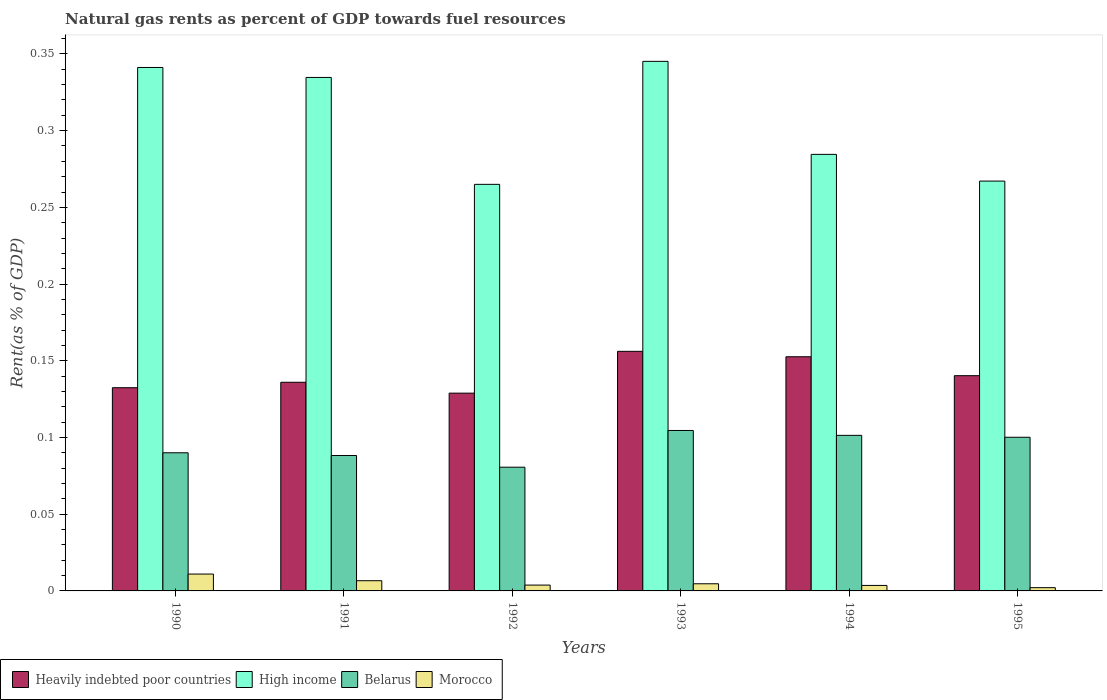Are the number of bars per tick equal to the number of legend labels?
Provide a short and direct response. Yes. How many bars are there on the 5th tick from the left?
Your answer should be very brief. 4. What is the label of the 2nd group of bars from the left?
Provide a short and direct response. 1991. In how many cases, is the number of bars for a given year not equal to the number of legend labels?
Make the answer very short. 0. What is the matural gas rent in Heavily indebted poor countries in 1995?
Provide a succinct answer. 0.14. Across all years, what is the maximum matural gas rent in Morocco?
Ensure brevity in your answer.  0.01. Across all years, what is the minimum matural gas rent in Belarus?
Make the answer very short. 0.08. In which year was the matural gas rent in Belarus maximum?
Your response must be concise. 1993. What is the total matural gas rent in High income in the graph?
Offer a very short reply. 1.84. What is the difference between the matural gas rent in Belarus in 1992 and that in 1995?
Give a very brief answer. -0.02. What is the difference between the matural gas rent in Heavily indebted poor countries in 1994 and the matural gas rent in High income in 1990?
Provide a short and direct response. -0.19. What is the average matural gas rent in Morocco per year?
Your response must be concise. 0.01. In the year 1990, what is the difference between the matural gas rent in Belarus and matural gas rent in Morocco?
Keep it short and to the point. 0.08. In how many years, is the matural gas rent in High income greater than 0.17 %?
Make the answer very short. 6. What is the ratio of the matural gas rent in Morocco in 1992 to that in 1995?
Provide a succinct answer. 1.79. Is the difference between the matural gas rent in Belarus in 1991 and 1992 greater than the difference between the matural gas rent in Morocco in 1991 and 1992?
Your response must be concise. Yes. What is the difference between the highest and the second highest matural gas rent in Heavily indebted poor countries?
Your answer should be compact. 0. What is the difference between the highest and the lowest matural gas rent in Heavily indebted poor countries?
Your response must be concise. 0.03. In how many years, is the matural gas rent in Heavily indebted poor countries greater than the average matural gas rent in Heavily indebted poor countries taken over all years?
Offer a terse response. 2. Is the sum of the matural gas rent in Morocco in 1993 and 1995 greater than the maximum matural gas rent in Heavily indebted poor countries across all years?
Your answer should be compact. No. What does the 2nd bar from the right in 1993 represents?
Make the answer very short. Belarus. How many bars are there?
Offer a very short reply. 24. Are all the bars in the graph horizontal?
Give a very brief answer. No. Are the values on the major ticks of Y-axis written in scientific E-notation?
Keep it short and to the point. No. Does the graph contain grids?
Provide a succinct answer. No. Where does the legend appear in the graph?
Make the answer very short. Bottom left. How many legend labels are there?
Give a very brief answer. 4. What is the title of the graph?
Make the answer very short. Natural gas rents as percent of GDP towards fuel resources. What is the label or title of the Y-axis?
Your answer should be compact. Rent(as % of GDP). What is the Rent(as % of GDP) of Heavily indebted poor countries in 1990?
Ensure brevity in your answer.  0.13. What is the Rent(as % of GDP) in High income in 1990?
Your answer should be compact. 0.34. What is the Rent(as % of GDP) in Belarus in 1990?
Ensure brevity in your answer.  0.09. What is the Rent(as % of GDP) in Morocco in 1990?
Provide a succinct answer. 0.01. What is the Rent(as % of GDP) in Heavily indebted poor countries in 1991?
Offer a terse response. 0.14. What is the Rent(as % of GDP) of High income in 1991?
Make the answer very short. 0.33. What is the Rent(as % of GDP) of Belarus in 1991?
Make the answer very short. 0.09. What is the Rent(as % of GDP) in Morocco in 1991?
Provide a short and direct response. 0.01. What is the Rent(as % of GDP) in Heavily indebted poor countries in 1992?
Provide a succinct answer. 0.13. What is the Rent(as % of GDP) of High income in 1992?
Your answer should be very brief. 0.26. What is the Rent(as % of GDP) of Belarus in 1992?
Offer a very short reply. 0.08. What is the Rent(as % of GDP) in Morocco in 1992?
Keep it short and to the point. 0. What is the Rent(as % of GDP) of Heavily indebted poor countries in 1993?
Your answer should be compact. 0.16. What is the Rent(as % of GDP) in High income in 1993?
Provide a succinct answer. 0.35. What is the Rent(as % of GDP) of Belarus in 1993?
Offer a terse response. 0.1. What is the Rent(as % of GDP) of Morocco in 1993?
Keep it short and to the point. 0. What is the Rent(as % of GDP) of Heavily indebted poor countries in 1994?
Provide a succinct answer. 0.15. What is the Rent(as % of GDP) in High income in 1994?
Provide a succinct answer. 0.28. What is the Rent(as % of GDP) of Belarus in 1994?
Your answer should be compact. 0.1. What is the Rent(as % of GDP) in Morocco in 1994?
Give a very brief answer. 0. What is the Rent(as % of GDP) of Heavily indebted poor countries in 1995?
Offer a terse response. 0.14. What is the Rent(as % of GDP) in High income in 1995?
Provide a succinct answer. 0.27. What is the Rent(as % of GDP) in Belarus in 1995?
Ensure brevity in your answer.  0.1. What is the Rent(as % of GDP) in Morocco in 1995?
Your answer should be compact. 0. Across all years, what is the maximum Rent(as % of GDP) in Heavily indebted poor countries?
Your answer should be compact. 0.16. Across all years, what is the maximum Rent(as % of GDP) of High income?
Provide a succinct answer. 0.35. Across all years, what is the maximum Rent(as % of GDP) in Belarus?
Provide a short and direct response. 0.1. Across all years, what is the maximum Rent(as % of GDP) of Morocco?
Provide a succinct answer. 0.01. Across all years, what is the minimum Rent(as % of GDP) in Heavily indebted poor countries?
Give a very brief answer. 0.13. Across all years, what is the minimum Rent(as % of GDP) of High income?
Keep it short and to the point. 0.26. Across all years, what is the minimum Rent(as % of GDP) of Belarus?
Provide a short and direct response. 0.08. Across all years, what is the minimum Rent(as % of GDP) of Morocco?
Your response must be concise. 0. What is the total Rent(as % of GDP) in Heavily indebted poor countries in the graph?
Offer a terse response. 0.85. What is the total Rent(as % of GDP) of High income in the graph?
Your response must be concise. 1.84. What is the total Rent(as % of GDP) of Belarus in the graph?
Your response must be concise. 0.57. What is the total Rent(as % of GDP) of Morocco in the graph?
Make the answer very short. 0.03. What is the difference between the Rent(as % of GDP) in Heavily indebted poor countries in 1990 and that in 1991?
Provide a succinct answer. -0. What is the difference between the Rent(as % of GDP) in High income in 1990 and that in 1991?
Provide a succinct answer. 0.01. What is the difference between the Rent(as % of GDP) of Belarus in 1990 and that in 1991?
Your answer should be compact. 0. What is the difference between the Rent(as % of GDP) of Morocco in 1990 and that in 1991?
Offer a terse response. 0. What is the difference between the Rent(as % of GDP) of Heavily indebted poor countries in 1990 and that in 1992?
Ensure brevity in your answer.  0. What is the difference between the Rent(as % of GDP) in High income in 1990 and that in 1992?
Ensure brevity in your answer.  0.08. What is the difference between the Rent(as % of GDP) in Belarus in 1990 and that in 1992?
Your answer should be compact. 0.01. What is the difference between the Rent(as % of GDP) of Morocco in 1990 and that in 1992?
Your answer should be very brief. 0.01. What is the difference between the Rent(as % of GDP) in Heavily indebted poor countries in 1990 and that in 1993?
Offer a terse response. -0.02. What is the difference between the Rent(as % of GDP) in High income in 1990 and that in 1993?
Your answer should be compact. -0. What is the difference between the Rent(as % of GDP) of Belarus in 1990 and that in 1993?
Your response must be concise. -0.01. What is the difference between the Rent(as % of GDP) in Morocco in 1990 and that in 1993?
Offer a terse response. 0.01. What is the difference between the Rent(as % of GDP) in Heavily indebted poor countries in 1990 and that in 1994?
Your answer should be very brief. -0.02. What is the difference between the Rent(as % of GDP) of High income in 1990 and that in 1994?
Provide a short and direct response. 0.06. What is the difference between the Rent(as % of GDP) in Belarus in 1990 and that in 1994?
Provide a succinct answer. -0.01. What is the difference between the Rent(as % of GDP) of Morocco in 1990 and that in 1994?
Give a very brief answer. 0.01. What is the difference between the Rent(as % of GDP) in Heavily indebted poor countries in 1990 and that in 1995?
Give a very brief answer. -0.01. What is the difference between the Rent(as % of GDP) of High income in 1990 and that in 1995?
Offer a very short reply. 0.07. What is the difference between the Rent(as % of GDP) of Belarus in 1990 and that in 1995?
Provide a short and direct response. -0.01. What is the difference between the Rent(as % of GDP) in Morocco in 1990 and that in 1995?
Your answer should be compact. 0.01. What is the difference between the Rent(as % of GDP) in Heavily indebted poor countries in 1991 and that in 1992?
Ensure brevity in your answer.  0.01. What is the difference between the Rent(as % of GDP) of High income in 1991 and that in 1992?
Offer a terse response. 0.07. What is the difference between the Rent(as % of GDP) of Belarus in 1991 and that in 1992?
Provide a succinct answer. 0.01. What is the difference between the Rent(as % of GDP) in Morocco in 1991 and that in 1992?
Offer a terse response. 0. What is the difference between the Rent(as % of GDP) in Heavily indebted poor countries in 1991 and that in 1993?
Keep it short and to the point. -0.02. What is the difference between the Rent(as % of GDP) in High income in 1991 and that in 1993?
Offer a terse response. -0.01. What is the difference between the Rent(as % of GDP) in Belarus in 1991 and that in 1993?
Your answer should be compact. -0.02. What is the difference between the Rent(as % of GDP) of Morocco in 1991 and that in 1993?
Make the answer very short. 0. What is the difference between the Rent(as % of GDP) of Heavily indebted poor countries in 1991 and that in 1994?
Give a very brief answer. -0.02. What is the difference between the Rent(as % of GDP) in High income in 1991 and that in 1994?
Offer a terse response. 0.05. What is the difference between the Rent(as % of GDP) in Belarus in 1991 and that in 1994?
Keep it short and to the point. -0.01. What is the difference between the Rent(as % of GDP) of Morocco in 1991 and that in 1994?
Give a very brief answer. 0. What is the difference between the Rent(as % of GDP) of Heavily indebted poor countries in 1991 and that in 1995?
Provide a succinct answer. -0. What is the difference between the Rent(as % of GDP) of High income in 1991 and that in 1995?
Provide a succinct answer. 0.07. What is the difference between the Rent(as % of GDP) in Belarus in 1991 and that in 1995?
Make the answer very short. -0.01. What is the difference between the Rent(as % of GDP) of Morocco in 1991 and that in 1995?
Your answer should be compact. 0. What is the difference between the Rent(as % of GDP) of Heavily indebted poor countries in 1992 and that in 1993?
Your answer should be very brief. -0.03. What is the difference between the Rent(as % of GDP) in High income in 1992 and that in 1993?
Offer a terse response. -0.08. What is the difference between the Rent(as % of GDP) of Belarus in 1992 and that in 1993?
Provide a succinct answer. -0.02. What is the difference between the Rent(as % of GDP) in Morocco in 1992 and that in 1993?
Ensure brevity in your answer.  -0. What is the difference between the Rent(as % of GDP) in Heavily indebted poor countries in 1992 and that in 1994?
Provide a short and direct response. -0.02. What is the difference between the Rent(as % of GDP) in High income in 1992 and that in 1994?
Ensure brevity in your answer.  -0.02. What is the difference between the Rent(as % of GDP) in Belarus in 1992 and that in 1994?
Your response must be concise. -0.02. What is the difference between the Rent(as % of GDP) of Heavily indebted poor countries in 1992 and that in 1995?
Ensure brevity in your answer.  -0.01. What is the difference between the Rent(as % of GDP) of High income in 1992 and that in 1995?
Your answer should be very brief. -0. What is the difference between the Rent(as % of GDP) in Belarus in 1992 and that in 1995?
Ensure brevity in your answer.  -0.02. What is the difference between the Rent(as % of GDP) in Morocco in 1992 and that in 1995?
Your answer should be very brief. 0. What is the difference between the Rent(as % of GDP) in Heavily indebted poor countries in 1993 and that in 1994?
Give a very brief answer. 0. What is the difference between the Rent(as % of GDP) of High income in 1993 and that in 1994?
Make the answer very short. 0.06. What is the difference between the Rent(as % of GDP) of Belarus in 1993 and that in 1994?
Make the answer very short. 0. What is the difference between the Rent(as % of GDP) of Morocco in 1993 and that in 1994?
Offer a very short reply. 0. What is the difference between the Rent(as % of GDP) in Heavily indebted poor countries in 1993 and that in 1995?
Make the answer very short. 0.02. What is the difference between the Rent(as % of GDP) of High income in 1993 and that in 1995?
Your answer should be very brief. 0.08. What is the difference between the Rent(as % of GDP) in Belarus in 1993 and that in 1995?
Your response must be concise. 0. What is the difference between the Rent(as % of GDP) in Morocco in 1993 and that in 1995?
Provide a short and direct response. 0. What is the difference between the Rent(as % of GDP) of Heavily indebted poor countries in 1994 and that in 1995?
Your answer should be very brief. 0.01. What is the difference between the Rent(as % of GDP) in High income in 1994 and that in 1995?
Offer a terse response. 0.02. What is the difference between the Rent(as % of GDP) in Belarus in 1994 and that in 1995?
Make the answer very short. 0. What is the difference between the Rent(as % of GDP) of Morocco in 1994 and that in 1995?
Keep it short and to the point. 0. What is the difference between the Rent(as % of GDP) of Heavily indebted poor countries in 1990 and the Rent(as % of GDP) of High income in 1991?
Your answer should be compact. -0.2. What is the difference between the Rent(as % of GDP) in Heavily indebted poor countries in 1990 and the Rent(as % of GDP) in Belarus in 1991?
Your response must be concise. 0.04. What is the difference between the Rent(as % of GDP) of Heavily indebted poor countries in 1990 and the Rent(as % of GDP) of Morocco in 1991?
Offer a very short reply. 0.13. What is the difference between the Rent(as % of GDP) of High income in 1990 and the Rent(as % of GDP) of Belarus in 1991?
Your answer should be compact. 0.25. What is the difference between the Rent(as % of GDP) in High income in 1990 and the Rent(as % of GDP) in Morocco in 1991?
Keep it short and to the point. 0.33. What is the difference between the Rent(as % of GDP) in Belarus in 1990 and the Rent(as % of GDP) in Morocco in 1991?
Make the answer very short. 0.08. What is the difference between the Rent(as % of GDP) in Heavily indebted poor countries in 1990 and the Rent(as % of GDP) in High income in 1992?
Offer a terse response. -0.13. What is the difference between the Rent(as % of GDP) in Heavily indebted poor countries in 1990 and the Rent(as % of GDP) in Belarus in 1992?
Provide a succinct answer. 0.05. What is the difference between the Rent(as % of GDP) of Heavily indebted poor countries in 1990 and the Rent(as % of GDP) of Morocco in 1992?
Provide a short and direct response. 0.13. What is the difference between the Rent(as % of GDP) in High income in 1990 and the Rent(as % of GDP) in Belarus in 1992?
Give a very brief answer. 0.26. What is the difference between the Rent(as % of GDP) in High income in 1990 and the Rent(as % of GDP) in Morocco in 1992?
Keep it short and to the point. 0.34. What is the difference between the Rent(as % of GDP) in Belarus in 1990 and the Rent(as % of GDP) in Morocco in 1992?
Offer a terse response. 0.09. What is the difference between the Rent(as % of GDP) of Heavily indebted poor countries in 1990 and the Rent(as % of GDP) of High income in 1993?
Provide a succinct answer. -0.21. What is the difference between the Rent(as % of GDP) in Heavily indebted poor countries in 1990 and the Rent(as % of GDP) in Belarus in 1993?
Offer a very short reply. 0.03. What is the difference between the Rent(as % of GDP) of Heavily indebted poor countries in 1990 and the Rent(as % of GDP) of Morocco in 1993?
Provide a short and direct response. 0.13. What is the difference between the Rent(as % of GDP) in High income in 1990 and the Rent(as % of GDP) in Belarus in 1993?
Make the answer very short. 0.24. What is the difference between the Rent(as % of GDP) in High income in 1990 and the Rent(as % of GDP) in Morocco in 1993?
Ensure brevity in your answer.  0.34. What is the difference between the Rent(as % of GDP) of Belarus in 1990 and the Rent(as % of GDP) of Morocco in 1993?
Provide a succinct answer. 0.09. What is the difference between the Rent(as % of GDP) in Heavily indebted poor countries in 1990 and the Rent(as % of GDP) in High income in 1994?
Keep it short and to the point. -0.15. What is the difference between the Rent(as % of GDP) in Heavily indebted poor countries in 1990 and the Rent(as % of GDP) in Belarus in 1994?
Keep it short and to the point. 0.03. What is the difference between the Rent(as % of GDP) of Heavily indebted poor countries in 1990 and the Rent(as % of GDP) of Morocco in 1994?
Give a very brief answer. 0.13. What is the difference between the Rent(as % of GDP) of High income in 1990 and the Rent(as % of GDP) of Belarus in 1994?
Offer a very short reply. 0.24. What is the difference between the Rent(as % of GDP) in High income in 1990 and the Rent(as % of GDP) in Morocco in 1994?
Your answer should be very brief. 0.34. What is the difference between the Rent(as % of GDP) of Belarus in 1990 and the Rent(as % of GDP) of Morocco in 1994?
Provide a succinct answer. 0.09. What is the difference between the Rent(as % of GDP) of Heavily indebted poor countries in 1990 and the Rent(as % of GDP) of High income in 1995?
Offer a terse response. -0.13. What is the difference between the Rent(as % of GDP) of Heavily indebted poor countries in 1990 and the Rent(as % of GDP) of Belarus in 1995?
Provide a short and direct response. 0.03. What is the difference between the Rent(as % of GDP) in Heavily indebted poor countries in 1990 and the Rent(as % of GDP) in Morocco in 1995?
Your answer should be compact. 0.13. What is the difference between the Rent(as % of GDP) in High income in 1990 and the Rent(as % of GDP) in Belarus in 1995?
Give a very brief answer. 0.24. What is the difference between the Rent(as % of GDP) in High income in 1990 and the Rent(as % of GDP) in Morocco in 1995?
Give a very brief answer. 0.34. What is the difference between the Rent(as % of GDP) of Belarus in 1990 and the Rent(as % of GDP) of Morocco in 1995?
Your answer should be very brief. 0.09. What is the difference between the Rent(as % of GDP) in Heavily indebted poor countries in 1991 and the Rent(as % of GDP) in High income in 1992?
Your answer should be compact. -0.13. What is the difference between the Rent(as % of GDP) of Heavily indebted poor countries in 1991 and the Rent(as % of GDP) of Belarus in 1992?
Keep it short and to the point. 0.06. What is the difference between the Rent(as % of GDP) in Heavily indebted poor countries in 1991 and the Rent(as % of GDP) in Morocco in 1992?
Your response must be concise. 0.13. What is the difference between the Rent(as % of GDP) in High income in 1991 and the Rent(as % of GDP) in Belarus in 1992?
Ensure brevity in your answer.  0.25. What is the difference between the Rent(as % of GDP) in High income in 1991 and the Rent(as % of GDP) in Morocco in 1992?
Provide a short and direct response. 0.33. What is the difference between the Rent(as % of GDP) of Belarus in 1991 and the Rent(as % of GDP) of Morocco in 1992?
Keep it short and to the point. 0.08. What is the difference between the Rent(as % of GDP) in Heavily indebted poor countries in 1991 and the Rent(as % of GDP) in High income in 1993?
Keep it short and to the point. -0.21. What is the difference between the Rent(as % of GDP) of Heavily indebted poor countries in 1991 and the Rent(as % of GDP) of Belarus in 1993?
Offer a terse response. 0.03. What is the difference between the Rent(as % of GDP) in Heavily indebted poor countries in 1991 and the Rent(as % of GDP) in Morocco in 1993?
Give a very brief answer. 0.13. What is the difference between the Rent(as % of GDP) in High income in 1991 and the Rent(as % of GDP) in Belarus in 1993?
Provide a succinct answer. 0.23. What is the difference between the Rent(as % of GDP) of High income in 1991 and the Rent(as % of GDP) of Morocco in 1993?
Your answer should be compact. 0.33. What is the difference between the Rent(as % of GDP) in Belarus in 1991 and the Rent(as % of GDP) in Morocco in 1993?
Ensure brevity in your answer.  0.08. What is the difference between the Rent(as % of GDP) in Heavily indebted poor countries in 1991 and the Rent(as % of GDP) in High income in 1994?
Offer a very short reply. -0.15. What is the difference between the Rent(as % of GDP) in Heavily indebted poor countries in 1991 and the Rent(as % of GDP) in Belarus in 1994?
Offer a very short reply. 0.03. What is the difference between the Rent(as % of GDP) in Heavily indebted poor countries in 1991 and the Rent(as % of GDP) in Morocco in 1994?
Ensure brevity in your answer.  0.13. What is the difference between the Rent(as % of GDP) in High income in 1991 and the Rent(as % of GDP) in Belarus in 1994?
Give a very brief answer. 0.23. What is the difference between the Rent(as % of GDP) in High income in 1991 and the Rent(as % of GDP) in Morocco in 1994?
Offer a terse response. 0.33. What is the difference between the Rent(as % of GDP) in Belarus in 1991 and the Rent(as % of GDP) in Morocco in 1994?
Keep it short and to the point. 0.08. What is the difference between the Rent(as % of GDP) of Heavily indebted poor countries in 1991 and the Rent(as % of GDP) of High income in 1995?
Offer a very short reply. -0.13. What is the difference between the Rent(as % of GDP) of Heavily indebted poor countries in 1991 and the Rent(as % of GDP) of Belarus in 1995?
Ensure brevity in your answer.  0.04. What is the difference between the Rent(as % of GDP) of Heavily indebted poor countries in 1991 and the Rent(as % of GDP) of Morocco in 1995?
Provide a short and direct response. 0.13. What is the difference between the Rent(as % of GDP) of High income in 1991 and the Rent(as % of GDP) of Belarus in 1995?
Offer a very short reply. 0.23. What is the difference between the Rent(as % of GDP) in High income in 1991 and the Rent(as % of GDP) in Morocco in 1995?
Give a very brief answer. 0.33. What is the difference between the Rent(as % of GDP) of Belarus in 1991 and the Rent(as % of GDP) of Morocco in 1995?
Your answer should be very brief. 0.09. What is the difference between the Rent(as % of GDP) in Heavily indebted poor countries in 1992 and the Rent(as % of GDP) in High income in 1993?
Provide a succinct answer. -0.22. What is the difference between the Rent(as % of GDP) in Heavily indebted poor countries in 1992 and the Rent(as % of GDP) in Belarus in 1993?
Provide a succinct answer. 0.02. What is the difference between the Rent(as % of GDP) of Heavily indebted poor countries in 1992 and the Rent(as % of GDP) of Morocco in 1993?
Give a very brief answer. 0.12. What is the difference between the Rent(as % of GDP) in High income in 1992 and the Rent(as % of GDP) in Belarus in 1993?
Provide a short and direct response. 0.16. What is the difference between the Rent(as % of GDP) in High income in 1992 and the Rent(as % of GDP) in Morocco in 1993?
Offer a terse response. 0.26. What is the difference between the Rent(as % of GDP) in Belarus in 1992 and the Rent(as % of GDP) in Morocco in 1993?
Your response must be concise. 0.08. What is the difference between the Rent(as % of GDP) of Heavily indebted poor countries in 1992 and the Rent(as % of GDP) of High income in 1994?
Your answer should be very brief. -0.16. What is the difference between the Rent(as % of GDP) in Heavily indebted poor countries in 1992 and the Rent(as % of GDP) in Belarus in 1994?
Make the answer very short. 0.03. What is the difference between the Rent(as % of GDP) in Heavily indebted poor countries in 1992 and the Rent(as % of GDP) in Morocco in 1994?
Give a very brief answer. 0.13. What is the difference between the Rent(as % of GDP) of High income in 1992 and the Rent(as % of GDP) of Belarus in 1994?
Your answer should be very brief. 0.16. What is the difference between the Rent(as % of GDP) of High income in 1992 and the Rent(as % of GDP) of Morocco in 1994?
Make the answer very short. 0.26. What is the difference between the Rent(as % of GDP) of Belarus in 1992 and the Rent(as % of GDP) of Morocco in 1994?
Give a very brief answer. 0.08. What is the difference between the Rent(as % of GDP) of Heavily indebted poor countries in 1992 and the Rent(as % of GDP) of High income in 1995?
Make the answer very short. -0.14. What is the difference between the Rent(as % of GDP) of Heavily indebted poor countries in 1992 and the Rent(as % of GDP) of Belarus in 1995?
Your answer should be very brief. 0.03. What is the difference between the Rent(as % of GDP) of Heavily indebted poor countries in 1992 and the Rent(as % of GDP) of Morocco in 1995?
Offer a terse response. 0.13. What is the difference between the Rent(as % of GDP) in High income in 1992 and the Rent(as % of GDP) in Belarus in 1995?
Offer a terse response. 0.16. What is the difference between the Rent(as % of GDP) in High income in 1992 and the Rent(as % of GDP) in Morocco in 1995?
Your response must be concise. 0.26. What is the difference between the Rent(as % of GDP) of Belarus in 1992 and the Rent(as % of GDP) of Morocco in 1995?
Your answer should be very brief. 0.08. What is the difference between the Rent(as % of GDP) in Heavily indebted poor countries in 1993 and the Rent(as % of GDP) in High income in 1994?
Your response must be concise. -0.13. What is the difference between the Rent(as % of GDP) in Heavily indebted poor countries in 1993 and the Rent(as % of GDP) in Belarus in 1994?
Offer a very short reply. 0.05. What is the difference between the Rent(as % of GDP) of Heavily indebted poor countries in 1993 and the Rent(as % of GDP) of Morocco in 1994?
Offer a terse response. 0.15. What is the difference between the Rent(as % of GDP) in High income in 1993 and the Rent(as % of GDP) in Belarus in 1994?
Give a very brief answer. 0.24. What is the difference between the Rent(as % of GDP) of High income in 1993 and the Rent(as % of GDP) of Morocco in 1994?
Your answer should be very brief. 0.34. What is the difference between the Rent(as % of GDP) in Belarus in 1993 and the Rent(as % of GDP) in Morocco in 1994?
Keep it short and to the point. 0.1. What is the difference between the Rent(as % of GDP) of Heavily indebted poor countries in 1993 and the Rent(as % of GDP) of High income in 1995?
Provide a succinct answer. -0.11. What is the difference between the Rent(as % of GDP) in Heavily indebted poor countries in 1993 and the Rent(as % of GDP) in Belarus in 1995?
Your response must be concise. 0.06. What is the difference between the Rent(as % of GDP) of Heavily indebted poor countries in 1993 and the Rent(as % of GDP) of Morocco in 1995?
Ensure brevity in your answer.  0.15. What is the difference between the Rent(as % of GDP) in High income in 1993 and the Rent(as % of GDP) in Belarus in 1995?
Make the answer very short. 0.24. What is the difference between the Rent(as % of GDP) of High income in 1993 and the Rent(as % of GDP) of Morocco in 1995?
Ensure brevity in your answer.  0.34. What is the difference between the Rent(as % of GDP) in Belarus in 1993 and the Rent(as % of GDP) in Morocco in 1995?
Your answer should be compact. 0.1. What is the difference between the Rent(as % of GDP) in Heavily indebted poor countries in 1994 and the Rent(as % of GDP) in High income in 1995?
Make the answer very short. -0.11. What is the difference between the Rent(as % of GDP) of Heavily indebted poor countries in 1994 and the Rent(as % of GDP) of Belarus in 1995?
Your response must be concise. 0.05. What is the difference between the Rent(as % of GDP) in Heavily indebted poor countries in 1994 and the Rent(as % of GDP) in Morocco in 1995?
Provide a succinct answer. 0.15. What is the difference between the Rent(as % of GDP) of High income in 1994 and the Rent(as % of GDP) of Belarus in 1995?
Offer a very short reply. 0.18. What is the difference between the Rent(as % of GDP) of High income in 1994 and the Rent(as % of GDP) of Morocco in 1995?
Your answer should be very brief. 0.28. What is the difference between the Rent(as % of GDP) of Belarus in 1994 and the Rent(as % of GDP) of Morocco in 1995?
Your answer should be compact. 0.1. What is the average Rent(as % of GDP) in Heavily indebted poor countries per year?
Offer a very short reply. 0.14. What is the average Rent(as % of GDP) of High income per year?
Keep it short and to the point. 0.31. What is the average Rent(as % of GDP) of Belarus per year?
Your answer should be very brief. 0.09. What is the average Rent(as % of GDP) in Morocco per year?
Give a very brief answer. 0.01. In the year 1990, what is the difference between the Rent(as % of GDP) in Heavily indebted poor countries and Rent(as % of GDP) in High income?
Ensure brevity in your answer.  -0.21. In the year 1990, what is the difference between the Rent(as % of GDP) in Heavily indebted poor countries and Rent(as % of GDP) in Belarus?
Provide a succinct answer. 0.04. In the year 1990, what is the difference between the Rent(as % of GDP) of Heavily indebted poor countries and Rent(as % of GDP) of Morocco?
Your response must be concise. 0.12. In the year 1990, what is the difference between the Rent(as % of GDP) of High income and Rent(as % of GDP) of Belarus?
Your answer should be very brief. 0.25. In the year 1990, what is the difference between the Rent(as % of GDP) of High income and Rent(as % of GDP) of Morocco?
Make the answer very short. 0.33. In the year 1990, what is the difference between the Rent(as % of GDP) in Belarus and Rent(as % of GDP) in Morocco?
Your answer should be compact. 0.08. In the year 1991, what is the difference between the Rent(as % of GDP) in Heavily indebted poor countries and Rent(as % of GDP) in High income?
Your response must be concise. -0.2. In the year 1991, what is the difference between the Rent(as % of GDP) of Heavily indebted poor countries and Rent(as % of GDP) of Belarus?
Keep it short and to the point. 0.05. In the year 1991, what is the difference between the Rent(as % of GDP) of Heavily indebted poor countries and Rent(as % of GDP) of Morocco?
Your answer should be very brief. 0.13. In the year 1991, what is the difference between the Rent(as % of GDP) of High income and Rent(as % of GDP) of Belarus?
Keep it short and to the point. 0.25. In the year 1991, what is the difference between the Rent(as % of GDP) in High income and Rent(as % of GDP) in Morocco?
Keep it short and to the point. 0.33. In the year 1991, what is the difference between the Rent(as % of GDP) of Belarus and Rent(as % of GDP) of Morocco?
Offer a terse response. 0.08. In the year 1992, what is the difference between the Rent(as % of GDP) of Heavily indebted poor countries and Rent(as % of GDP) of High income?
Offer a very short reply. -0.14. In the year 1992, what is the difference between the Rent(as % of GDP) of Heavily indebted poor countries and Rent(as % of GDP) of Belarus?
Make the answer very short. 0.05. In the year 1992, what is the difference between the Rent(as % of GDP) in Heavily indebted poor countries and Rent(as % of GDP) in Morocco?
Keep it short and to the point. 0.13. In the year 1992, what is the difference between the Rent(as % of GDP) of High income and Rent(as % of GDP) of Belarus?
Your answer should be very brief. 0.18. In the year 1992, what is the difference between the Rent(as % of GDP) in High income and Rent(as % of GDP) in Morocco?
Make the answer very short. 0.26. In the year 1992, what is the difference between the Rent(as % of GDP) in Belarus and Rent(as % of GDP) in Morocco?
Offer a terse response. 0.08. In the year 1993, what is the difference between the Rent(as % of GDP) in Heavily indebted poor countries and Rent(as % of GDP) in High income?
Provide a succinct answer. -0.19. In the year 1993, what is the difference between the Rent(as % of GDP) in Heavily indebted poor countries and Rent(as % of GDP) in Belarus?
Your response must be concise. 0.05. In the year 1993, what is the difference between the Rent(as % of GDP) of Heavily indebted poor countries and Rent(as % of GDP) of Morocco?
Provide a short and direct response. 0.15. In the year 1993, what is the difference between the Rent(as % of GDP) in High income and Rent(as % of GDP) in Belarus?
Provide a short and direct response. 0.24. In the year 1993, what is the difference between the Rent(as % of GDP) of High income and Rent(as % of GDP) of Morocco?
Give a very brief answer. 0.34. In the year 1993, what is the difference between the Rent(as % of GDP) in Belarus and Rent(as % of GDP) in Morocco?
Offer a terse response. 0.1. In the year 1994, what is the difference between the Rent(as % of GDP) in Heavily indebted poor countries and Rent(as % of GDP) in High income?
Ensure brevity in your answer.  -0.13. In the year 1994, what is the difference between the Rent(as % of GDP) of Heavily indebted poor countries and Rent(as % of GDP) of Belarus?
Your response must be concise. 0.05. In the year 1994, what is the difference between the Rent(as % of GDP) of Heavily indebted poor countries and Rent(as % of GDP) of Morocco?
Your answer should be very brief. 0.15. In the year 1994, what is the difference between the Rent(as % of GDP) of High income and Rent(as % of GDP) of Belarus?
Offer a very short reply. 0.18. In the year 1994, what is the difference between the Rent(as % of GDP) in High income and Rent(as % of GDP) in Morocco?
Your response must be concise. 0.28. In the year 1994, what is the difference between the Rent(as % of GDP) of Belarus and Rent(as % of GDP) of Morocco?
Provide a short and direct response. 0.1. In the year 1995, what is the difference between the Rent(as % of GDP) in Heavily indebted poor countries and Rent(as % of GDP) in High income?
Provide a short and direct response. -0.13. In the year 1995, what is the difference between the Rent(as % of GDP) of Heavily indebted poor countries and Rent(as % of GDP) of Belarus?
Provide a short and direct response. 0.04. In the year 1995, what is the difference between the Rent(as % of GDP) in Heavily indebted poor countries and Rent(as % of GDP) in Morocco?
Your response must be concise. 0.14. In the year 1995, what is the difference between the Rent(as % of GDP) in High income and Rent(as % of GDP) in Belarus?
Offer a very short reply. 0.17. In the year 1995, what is the difference between the Rent(as % of GDP) in High income and Rent(as % of GDP) in Morocco?
Offer a terse response. 0.27. In the year 1995, what is the difference between the Rent(as % of GDP) in Belarus and Rent(as % of GDP) in Morocco?
Offer a terse response. 0.1. What is the ratio of the Rent(as % of GDP) in Heavily indebted poor countries in 1990 to that in 1991?
Give a very brief answer. 0.97. What is the ratio of the Rent(as % of GDP) of High income in 1990 to that in 1991?
Keep it short and to the point. 1.02. What is the ratio of the Rent(as % of GDP) of Belarus in 1990 to that in 1991?
Your answer should be very brief. 1.02. What is the ratio of the Rent(as % of GDP) of Morocco in 1990 to that in 1991?
Your answer should be compact. 1.65. What is the ratio of the Rent(as % of GDP) in Heavily indebted poor countries in 1990 to that in 1992?
Provide a short and direct response. 1.03. What is the ratio of the Rent(as % of GDP) of High income in 1990 to that in 1992?
Ensure brevity in your answer.  1.29. What is the ratio of the Rent(as % of GDP) in Belarus in 1990 to that in 1992?
Your answer should be very brief. 1.12. What is the ratio of the Rent(as % of GDP) in Morocco in 1990 to that in 1992?
Provide a short and direct response. 2.89. What is the ratio of the Rent(as % of GDP) in Heavily indebted poor countries in 1990 to that in 1993?
Provide a short and direct response. 0.85. What is the ratio of the Rent(as % of GDP) of High income in 1990 to that in 1993?
Keep it short and to the point. 0.99. What is the ratio of the Rent(as % of GDP) in Belarus in 1990 to that in 1993?
Give a very brief answer. 0.86. What is the ratio of the Rent(as % of GDP) of Morocco in 1990 to that in 1993?
Keep it short and to the point. 2.36. What is the ratio of the Rent(as % of GDP) in Heavily indebted poor countries in 1990 to that in 1994?
Your answer should be very brief. 0.87. What is the ratio of the Rent(as % of GDP) of High income in 1990 to that in 1994?
Ensure brevity in your answer.  1.2. What is the ratio of the Rent(as % of GDP) of Belarus in 1990 to that in 1994?
Make the answer very short. 0.89. What is the ratio of the Rent(as % of GDP) in Morocco in 1990 to that in 1994?
Offer a terse response. 3.07. What is the ratio of the Rent(as % of GDP) in Heavily indebted poor countries in 1990 to that in 1995?
Keep it short and to the point. 0.94. What is the ratio of the Rent(as % of GDP) in High income in 1990 to that in 1995?
Give a very brief answer. 1.28. What is the ratio of the Rent(as % of GDP) of Belarus in 1990 to that in 1995?
Make the answer very short. 0.9. What is the ratio of the Rent(as % of GDP) of Morocco in 1990 to that in 1995?
Your answer should be very brief. 5.18. What is the ratio of the Rent(as % of GDP) in Heavily indebted poor countries in 1991 to that in 1992?
Provide a succinct answer. 1.05. What is the ratio of the Rent(as % of GDP) in High income in 1991 to that in 1992?
Keep it short and to the point. 1.26. What is the ratio of the Rent(as % of GDP) of Belarus in 1991 to that in 1992?
Ensure brevity in your answer.  1.09. What is the ratio of the Rent(as % of GDP) in Morocco in 1991 to that in 1992?
Offer a very short reply. 1.75. What is the ratio of the Rent(as % of GDP) in Heavily indebted poor countries in 1991 to that in 1993?
Ensure brevity in your answer.  0.87. What is the ratio of the Rent(as % of GDP) in High income in 1991 to that in 1993?
Make the answer very short. 0.97. What is the ratio of the Rent(as % of GDP) of Belarus in 1991 to that in 1993?
Offer a very short reply. 0.84. What is the ratio of the Rent(as % of GDP) of Morocco in 1991 to that in 1993?
Provide a short and direct response. 1.43. What is the ratio of the Rent(as % of GDP) in Heavily indebted poor countries in 1991 to that in 1994?
Your response must be concise. 0.89. What is the ratio of the Rent(as % of GDP) of High income in 1991 to that in 1994?
Give a very brief answer. 1.18. What is the ratio of the Rent(as % of GDP) of Belarus in 1991 to that in 1994?
Give a very brief answer. 0.87. What is the ratio of the Rent(as % of GDP) in Morocco in 1991 to that in 1994?
Keep it short and to the point. 1.86. What is the ratio of the Rent(as % of GDP) of Heavily indebted poor countries in 1991 to that in 1995?
Provide a succinct answer. 0.97. What is the ratio of the Rent(as % of GDP) of High income in 1991 to that in 1995?
Provide a succinct answer. 1.25. What is the ratio of the Rent(as % of GDP) in Belarus in 1991 to that in 1995?
Offer a terse response. 0.88. What is the ratio of the Rent(as % of GDP) of Morocco in 1991 to that in 1995?
Offer a very short reply. 3.14. What is the ratio of the Rent(as % of GDP) in Heavily indebted poor countries in 1992 to that in 1993?
Give a very brief answer. 0.83. What is the ratio of the Rent(as % of GDP) of High income in 1992 to that in 1993?
Keep it short and to the point. 0.77. What is the ratio of the Rent(as % of GDP) of Belarus in 1992 to that in 1993?
Provide a short and direct response. 0.77. What is the ratio of the Rent(as % of GDP) of Morocco in 1992 to that in 1993?
Your response must be concise. 0.82. What is the ratio of the Rent(as % of GDP) of Heavily indebted poor countries in 1992 to that in 1994?
Make the answer very short. 0.84. What is the ratio of the Rent(as % of GDP) in High income in 1992 to that in 1994?
Provide a short and direct response. 0.93. What is the ratio of the Rent(as % of GDP) of Belarus in 1992 to that in 1994?
Ensure brevity in your answer.  0.8. What is the ratio of the Rent(as % of GDP) in Morocco in 1992 to that in 1994?
Offer a very short reply. 1.06. What is the ratio of the Rent(as % of GDP) of Heavily indebted poor countries in 1992 to that in 1995?
Keep it short and to the point. 0.92. What is the ratio of the Rent(as % of GDP) in High income in 1992 to that in 1995?
Your response must be concise. 0.99. What is the ratio of the Rent(as % of GDP) of Belarus in 1992 to that in 1995?
Provide a succinct answer. 0.81. What is the ratio of the Rent(as % of GDP) of Morocco in 1992 to that in 1995?
Give a very brief answer. 1.79. What is the ratio of the Rent(as % of GDP) of Heavily indebted poor countries in 1993 to that in 1994?
Give a very brief answer. 1.02. What is the ratio of the Rent(as % of GDP) in High income in 1993 to that in 1994?
Your answer should be compact. 1.21. What is the ratio of the Rent(as % of GDP) in Belarus in 1993 to that in 1994?
Give a very brief answer. 1.03. What is the ratio of the Rent(as % of GDP) of Morocco in 1993 to that in 1994?
Provide a short and direct response. 1.3. What is the ratio of the Rent(as % of GDP) of Heavily indebted poor countries in 1993 to that in 1995?
Your answer should be compact. 1.11. What is the ratio of the Rent(as % of GDP) in High income in 1993 to that in 1995?
Your answer should be very brief. 1.29. What is the ratio of the Rent(as % of GDP) in Belarus in 1993 to that in 1995?
Your answer should be compact. 1.04. What is the ratio of the Rent(as % of GDP) of Morocco in 1993 to that in 1995?
Make the answer very short. 2.2. What is the ratio of the Rent(as % of GDP) in Heavily indebted poor countries in 1994 to that in 1995?
Provide a short and direct response. 1.09. What is the ratio of the Rent(as % of GDP) of High income in 1994 to that in 1995?
Ensure brevity in your answer.  1.07. What is the ratio of the Rent(as % of GDP) in Belarus in 1994 to that in 1995?
Provide a succinct answer. 1.01. What is the ratio of the Rent(as % of GDP) in Morocco in 1994 to that in 1995?
Your answer should be very brief. 1.69. What is the difference between the highest and the second highest Rent(as % of GDP) of Heavily indebted poor countries?
Keep it short and to the point. 0. What is the difference between the highest and the second highest Rent(as % of GDP) in High income?
Give a very brief answer. 0. What is the difference between the highest and the second highest Rent(as % of GDP) in Belarus?
Ensure brevity in your answer.  0. What is the difference between the highest and the second highest Rent(as % of GDP) in Morocco?
Offer a very short reply. 0. What is the difference between the highest and the lowest Rent(as % of GDP) in Heavily indebted poor countries?
Your response must be concise. 0.03. What is the difference between the highest and the lowest Rent(as % of GDP) in High income?
Keep it short and to the point. 0.08. What is the difference between the highest and the lowest Rent(as % of GDP) of Belarus?
Your answer should be compact. 0.02. What is the difference between the highest and the lowest Rent(as % of GDP) of Morocco?
Provide a short and direct response. 0.01. 